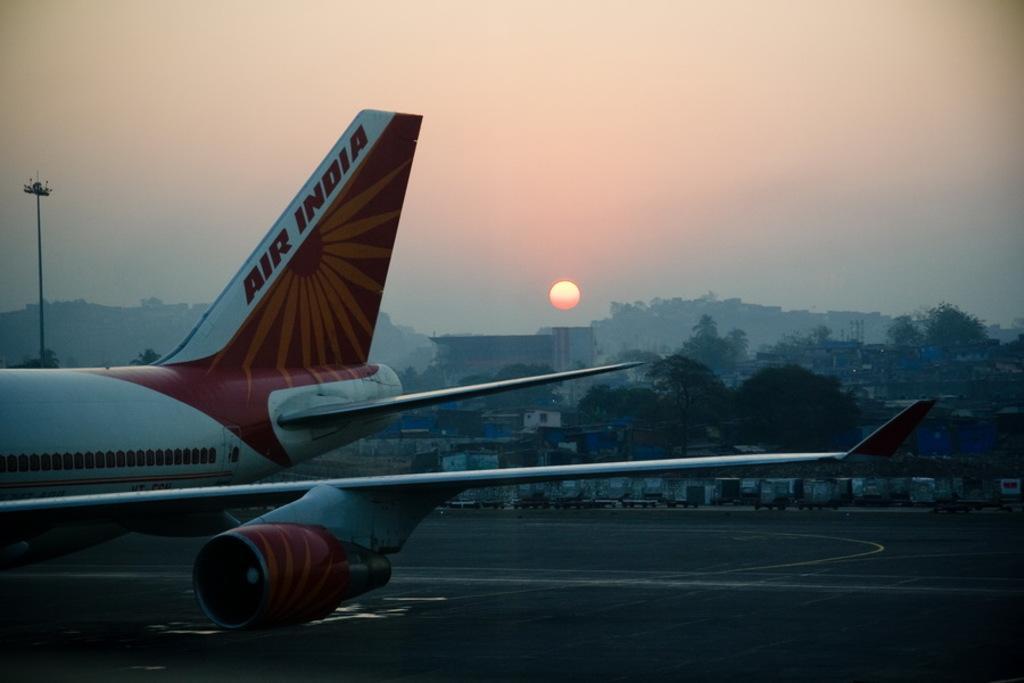Can you describe this image briefly? This picture is clicked outside. On the left there is an airplane which is in the air. In the background we can see the poles, sky and we can see the sun, trees and many other objects and we can see the houses. 